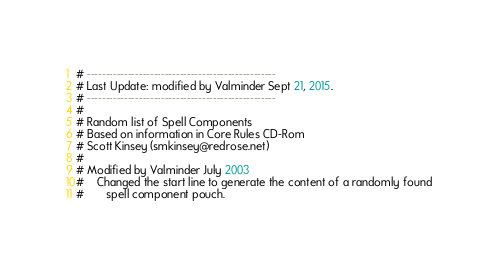Convert code to text. <code><loc_0><loc_0><loc_500><loc_500><_SQL_># ---------------------------------------------------
# Last Update: modified by Valminder Sept 21, 2015.
# ---------------------------------------------------
#
# Random list of Spell Components
# Based on information in Core Rules CD-Rom
# Scott Kinsey (smkinsey@redrose.net)
#
# Modified by Valminder July 2003
#    Changed the start line to generate the content of a randomly found
#       spell component pouch.</code> 